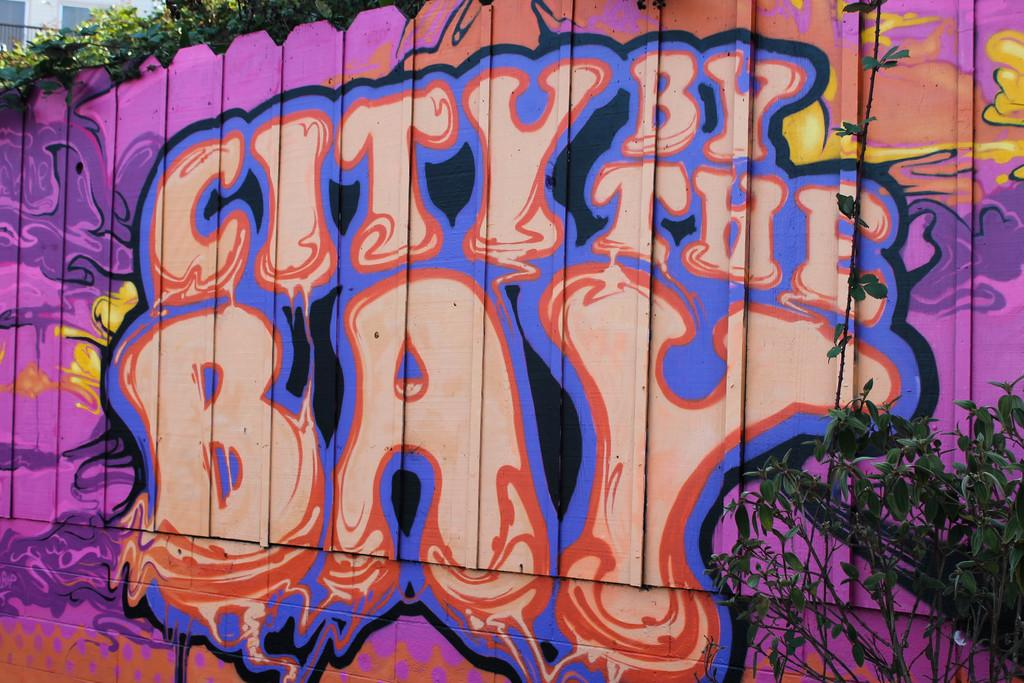What is on the wooden wall in the image? There is graffiti on a wooden wall in the image. What can be read in the graffiti? There is text in the graffiti. What type of vegetation is present in the image? There is a plant and trees in the image. What type of structure is visible in the image? There is a building in the image. What type of finger can be seen in the graffiti? There is no finger present in the graffiti or the image. What type of land is depicted in the image? The image does not depict a specific type of land; it shows a wooden wall with graffiti, a plant, trees, and a building. 